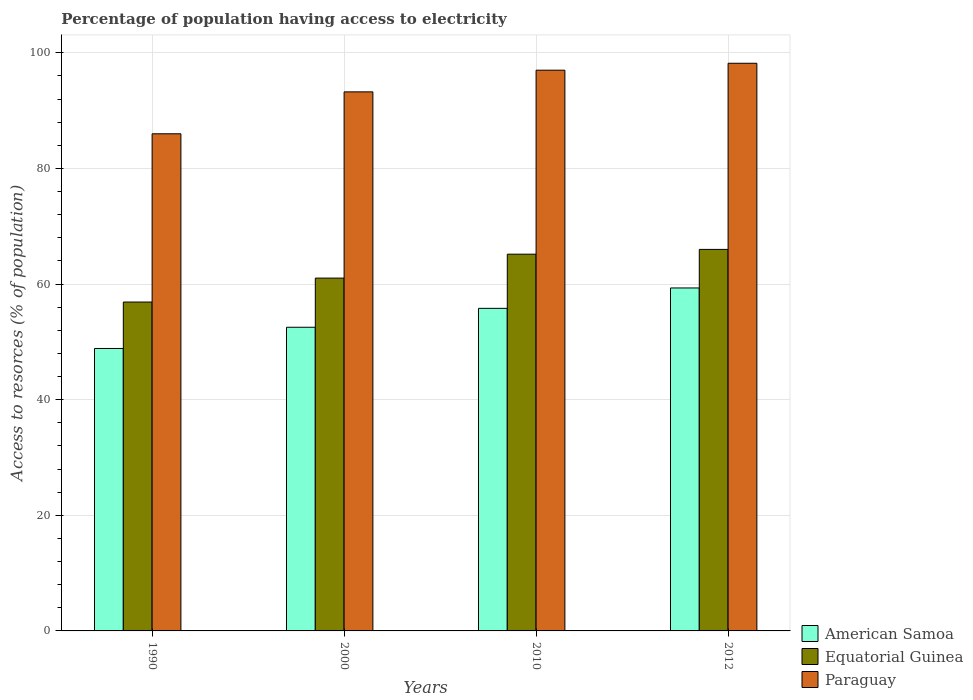How many groups of bars are there?
Give a very brief answer. 4. Are the number of bars per tick equal to the number of legend labels?
Provide a succinct answer. Yes. In how many cases, is the number of bars for a given year not equal to the number of legend labels?
Offer a terse response. 0. What is the percentage of population having access to electricity in Paraguay in 2010?
Ensure brevity in your answer.  97. Across all years, what is the minimum percentage of population having access to electricity in Paraguay?
Give a very brief answer. 86. What is the total percentage of population having access to electricity in Paraguay in the graph?
Give a very brief answer. 374.45. What is the difference between the percentage of population having access to electricity in American Samoa in 2000 and that in 2010?
Give a very brief answer. -3.27. What is the difference between the percentage of population having access to electricity in Equatorial Guinea in 2010 and the percentage of population having access to electricity in Paraguay in 1990?
Provide a succinct answer. -20.83. What is the average percentage of population having access to electricity in American Samoa per year?
Your response must be concise. 54.13. In the year 2010, what is the difference between the percentage of population having access to electricity in Paraguay and percentage of population having access to electricity in American Samoa?
Provide a short and direct response. 41.2. What is the ratio of the percentage of population having access to electricity in Paraguay in 2000 to that in 2010?
Make the answer very short. 0.96. What is the difference between the highest and the second highest percentage of population having access to electricity in American Samoa?
Give a very brief answer. 3.53. What is the difference between the highest and the lowest percentage of population having access to electricity in Equatorial Guinea?
Keep it short and to the point. 9.11. In how many years, is the percentage of population having access to electricity in American Samoa greater than the average percentage of population having access to electricity in American Samoa taken over all years?
Offer a terse response. 2. Is the sum of the percentage of population having access to electricity in American Samoa in 2000 and 2012 greater than the maximum percentage of population having access to electricity in Paraguay across all years?
Provide a succinct answer. Yes. What does the 1st bar from the left in 1990 represents?
Your answer should be compact. American Samoa. What does the 2nd bar from the right in 2012 represents?
Offer a very short reply. Equatorial Guinea. How many years are there in the graph?
Your answer should be very brief. 4. What is the difference between two consecutive major ticks on the Y-axis?
Give a very brief answer. 20. Does the graph contain grids?
Ensure brevity in your answer.  Yes. Where does the legend appear in the graph?
Your answer should be very brief. Bottom right. How many legend labels are there?
Offer a very short reply. 3. How are the legend labels stacked?
Your answer should be very brief. Vertical. What is the title of the graph?
Keep it short and to the point. Percentage of population having access to electricity. What is the label or title of the Y-axis?
Give a very brief answer. Access to resorces (% of population). What is the Access to resorces (% of population) in American Samoa in 1990?
Make the answer very short. 48.86. What is the Access to resorces (% of population) of Equatorial Guinea in 1990?
Your answer should be compact. 56.89. What is the Access to resorces (% of population) of American Samoa in 2000?
Make the answer very short. 52.53. What is the Access to resorces (% of population) in Equatorial Guinea in 2000?
Keep it short and to the point. 61.03. What is the Access to resorces (% of population) of Paraguay in 2000?
Provide a short and direct response. 93.25. What is the Access to resorces (% of population) in American Samoa in 2010?
Offer a terse response. 55.8. What is the Access to resorces (% of population) in Equatorial Guinea in 2010?
Your answer should be very brief. 65.17. What is the Access to resorces (% of population) in Paraguay in 2010?
Your answer should be very brief. 97. What is the Access to resorces (% of population) of American Samoa in 2012?
Offer a terse response. 59.33. What is the Access to resorces (% of population) of Equatorial Guinea in 2012?
Give a very brief answer. 66. What is the Access to resorces (% of population) in Paraguay in 2012?
Ensure brevity in your answer.  98.2. Across all years, what is the maximum Access to resorces (% of population) of American Samoa?
Your response must be concise. 59.33. Across all years, what is the maximum Access to resorces (% of population) of Equatorial Guinea?
Ensure brevity in your answer.  66. Across all years, what is the maximum Access to resorces (% of population) of Paraguay?
Your answer should be very brief. 98.2. Across all years, what is the minimum Access to resorces (% of population) of American Samoa?
Keep it short and to the point. 48.86. Across all years, what is the minimum Access to resorces (% of population) in Equatorial Guinea?
Keep it short and to the point. 56.89. What is the total Access to resorces (% of population) in American Samoa in the graph?
Give a very brief answer. 216.52. What is the total Access to resorces (% of population) in Equatorial Guinea in the graph?
Your answer should be compact. 249.1. What is the total Access to resorces (% of population) in Paraguay in the graph?
Ensure brevity in your answer.  374.45. What is the difference between the Access to resorces (% of population) in American Samoa in 1990 and that in 2000?
Offer a terse response. -3.67. What is the difference between the Access to resorces (% of population) in Equatorial Guinea in 1990 and that in 2000?
Ensure brevity in your answer.  -4.14. What is the difference between the Access to resorces (% of population) in Paraguay in 1990 and that in 2000?
Provide a succinct answer. -7.25. What is the difference between the Access to resorces (% of population) of American Samoa in 1990 and that in 2010?
Give a very brief answer. -6.94. What is the difference between the Access to resorces (% of population) of Equatorial Guinea in 1990 and that in 2010?
Your answer should be compact. -8.28. What is the difference between the Access to resorces (% of population) in Paraguay in 1990 and that in 2010?
Ensure brevity in your answer.  -11. What is the difference between the Access to resorces (% of population) in American Samoa in 1990 and that in 2012?
Your answer should be very brief. -10.47. What is the difference between the Access to resorces (% of population) of Equatorial Guinea in 1990 and that in 2012?
Your answer should be compact. -9.11. What is the difference between the Access to resorces (% of population) of Paraguay in 1990 and that in 2012?
Provide a succinct answer. -12.2. What is the difference between the Access to resorces (% of population) of American Samoa in 2000 and that in 2010?
Make the answer very short. -3.27. What is the difference between the Access to resorces (% of population) in Equatorial Guinea in 2000 and that in 2010?
Your answer should be compact. -4.14. What is the difference between the Access to resorces (% of population) of Paraguay in 2000 and that in 2010?
Offer a very short reply. -3.75. What is the difference between the Access to resorces (% of population) in American Samoa in 2000 and that in 2012?
Your answer should be very brief. -6.8. What is the difference between the Access to resorces (% of population) in Equatorial Guinea in 2000 and that in 2012?
Provide a short and direct response. -4.97. What is the difference between the Access to resorces (% of population) of Paraguay in 2000 and that in 2012?
Provide a short and direct response. -4.95. What is the difference between the Access to resorces (% of population) in American Samoa in 2010 and that in 2012?
Provide a short and direct response. -3.53. What is the difference between the Access to resorces (% of population) of Equatorial Guinea in 2010 and that in 2012?
Your response must be concise. -0.83. What is the difference between the Access to resorces (% of population) in American Samoa in 1990 and the Access to resorces (% of population) in Equatorial Guinea in 2000?
Offer a terse response. -12.17. What is the difference between the Access to resorces (% of population) in American Samoa in 1990 and the Access to resorces (% of population) in Paraguay in 2000?
Your answer should be compact. -44.39. What is the difference between the Access to resorces (% of population) of Equatorial Guinea in 1990 and the Access to resorces (% of population) of Paraguay in 2000?
Ensure brevity in your answer.  -36.36. What is the difference between the Access to resorces (% of population) in American Samoa in 1990 and the Access to resorces (% of population) in Equatorial Guinea in 2010?
Offer a terse response. -16.31. What is the difference between the Access to resorces (% of population) of American Samoa in 1990 and the Access to resorces (% of population) of Paraguay in 2010?
Provide a succinct answer. -48.14. What is the difference between the Access to resorces (% of population) in Equatorial Guinea in 1990 and the Access to resorces (% of population) in Paraguay in 2010?
Make the answer very short. -40.11. What is the difference between the Access to resorces (% of population) in American Samoa in 1990 and the Access to resorces (% of population) in Equatorial Guinea in 2012?
Ensure brevity in your answer.  -17.14. What is the difference between the Access to resorces (% of population) of American Samoa in 1990 and the Access to resorces (% of population) of Paraguay in 2012?
Give a very brief answer. -49.34. What is the difference between the Access to resorces (% of population) in Equatorial Guinea in 1990 and the Access to resorces (% of population) in Paraguay in 2012?
Your response must be concise. -41.31. What is the difference between the Access to resorces (% of population) of American Samoa in 2000 and the Access to resorces (% of population) of Equatorial Guinea in 2010?
Give a very brief answer. -12.64. What is the difference between the Access to resorces (% of population) in American Samoa in 2000 and the Access to resorces (% of population) in Paraguay in 2010?
Your answer should be very brief. -44.47. What is the difference between the Access to resorces (% of population) of Equatorial Guinea in 2000 and the Access to resorces (% of population) of Paraguay in 2010?
Provide a short and direct response. -35.97. What is the difference between the Access to resorces (% of population) of American Samoa in 2000 and the Access to resorces (% of population) of Equatorial Guinea in 2012?
Provide a succinct answer. -13.47. What is the difference between the Access to resorces (% of population) in American Samoa in 2000 and the Access to resorces (% of population) in Paraguay in 2012?
Offer a terse response. -45.67. What is the difference between the Access to resorces (% of population) in Equatorial Guinea in 2000 and the Access to resorces (% of population) in Paraguay in 2012?
Give a very brief answer. -37.17. What is the difference between the Access to resorces (% of population) of American Samoa in 2010 and the Access to resorces (% of population) of Equatorial Guinea in 2012?
Your answer should be compact. -10.2. What is the difference between the Access to resorces (% of population) of American Samoa in 2010 and the Access to resorces (% of population) of Paraguay in 2012?
Make the answer very short. -42.4. What is the difference between the Access to resorces (% of population) in Equatorial Guinea in 2010 and the Access to resorces (% of population) in Paraguay in 2012?
Your answer should be compact. -33.03. What is the average Access to resorces (% of population) in American Samoa per year?
Offer a very short reply. 54.13. What is the average Access to resorces (% of population) in Equatorial Guinea per year?
Make the answer very short. 62.27. What is the average Access to resorces (% of population) in Paraguay per year?
Provide a succinct answer. 93.61. In the year 1990, what is the difference between the Access to resorces (% of population) of American Samoa and Access to resorces (% of population) of Equatorial Guinea?
Ensure brevity in your answer.  -8.04. In the year 1990, what is the difference between the Access to resorces (% of population) of American Samoa and Access to resorces (% of population) of Paraguay?
Provide a succinct answer. -37.14. In the year 1990, what is the difference between the Access to resorces (% of population) in Equatorial Guinea and Access to resorces (% of population) in Paraguay?
Offer a very short reply. -29.11. In the year 2000, what is the difference between the Access to resorces (% of population) of American Samoa and Access to resorces (% of population) of Equatorial Guinea?
Offer a terse response. -8.5. In the year 2000, what is the difference between the Access to resorces (% of population) of American Samoa and Access to resorces (% of population) of Paraguay?
Your response must be concise. -40.72. In the year 2000, what is the difference between the Access to resorces (% of population) in Equatorial Guinea and Access to resorces (% of population) in Paraguay?
Provide a short and direct response. -32.22. In the year 2010, what is the difference between the Access to resorces (% of population) in American Samoa and Access to resorces (% of population) in Equatorial Guinea?
Ensure brevity in your answer.  -9.37. In the year 2010, what is the difference between the Access to resorces (% of population) of American Samoa and Access to resorces (% of population) of Paraguay?
Offer a terse response. -41.2. In the year 2010, what is the difference between the Access to resorces (% of population) of Equatorial Guinea and Access to resorces (% of population) of Paraguay?
Your response must be concise. -31.83. In the year 2012, what is the difference between the Access to resorces (% of population) of American Samoa and Access to resorces (% of population) of Equatorial Guinea?
Make the answer very short. -6.67. In the year 2012, what is the difference between the Access to resorces (% of population) of American Samoa and Access to resorces (% of population) of Paraguay?
Your answer should be very brief. -38.87. In the year 2012, what is the difference between the Access to resorces (% of population) in Equatorial Guinea and Access to resorces (% of population) in Paraguay?
Provide a short and direct response. -32.2. What is the ratio of the Access to resorces (% of population) of American Samoa in 1990 to that in 2000?
Provide a short and direct response. 0.93. What is the ratio of the Access to resorces (% of population) in Equatorial Guinea in 1990 to that in 2000?
Offer a terse response. 0.93. What is the ratio of the Access to resorces (% of population) of Paraguay in 1990 to that in 2000?
Make the answer very short. 0.92. What is the ratio of the Access to resorces (% of population) of American Samoa in 1990 to that in 2010?
Provide a succinct answer. 0.88. What is the ratio of the Access to resorces (% of population) in Equatorial Guinea in 1990 to that in 2010?
Your response must be concise. 0.87. What is the ratio of the Access to resorces (% of population) of Paraguay in 1990 to that in 2010?
Ensure brevity in your answer.  0.89. What is the ratio of the Access to resorces (% of population) of American Samoa in 1990 to that in 2012?
Provide a short and direct response. 0.82. What is the ratio of the Access to resorces (% of population) of Equatorial Guinea in 1990 to that in 2012?
Ensure brevity in your answer.  0.86. What is the ratio of the Access to resorces (% of population) of Paraguay in 1990 to that in 2012?
Your answer should be very brief. 0.88. What is the ratio of the Access to resorces (% of population) in American Samoa in 2000 to that in 2010?
Provide a short and direct response. 0.94. What is the ratio of the Access to resorces (% of population) of Equatorial Guinea in 2000 to that in 2010?
Make the answer very short. 0.94. What is the ratio of the Access to resorces (% of population) of Paraguay in 2000 to that in 2010?
Your response must be concise. 0.96. What is the ratio of the Access to resorces (% of population) in American Samoa in 2000 to that in 2012?
Offer a very short reply. 0.89. What is the ratio of the Access to resorces (% of population) of Equatorial Guinea in 2000 to that in 2012?
Provide a succinct answer. 0.92. What is the ratio of the Access to resorces (% of population) in Paraguay in 2000 to that in 2012?
Give a very brief answer. 0.95. What is the ratio of the Access to resorces (% of population) in American Samoa in 2010 to that in 2012?
Your answer should be very brief. 0.94. What is the ratio of the Access to resorces (% of population) in Equatorial Guinea in 2010 to that in 2012?
Offer a terse response. 0.99. What is the ratio of the Access to resorces (% of population) in Paraguay in 2010 to that in 2012?
Offer a very short reply. 0.99. What is the difference between the highest and the second highest Access to resorces (% of population) in American Samoa?
Ensure brevity in your answer.  3.53. What is the difference between the highest and the second highest Access to resorces (% of population) in Equatorial Guinea?
Offer a terse response. 0.83. What is the difference between the highest and the lowest Access to resorces (% of population) in American Samoa?
Provide a succinct answer. 10.47. What is the difference between the highest and the lowest Access to resorces (% of population) of Equatorial Guinea?
Your response must be concise. 9.11. What is the difference between the highest and the lowest Access to resorces (% of population) in Paraguay?
Make the answer very short. 12.2. 